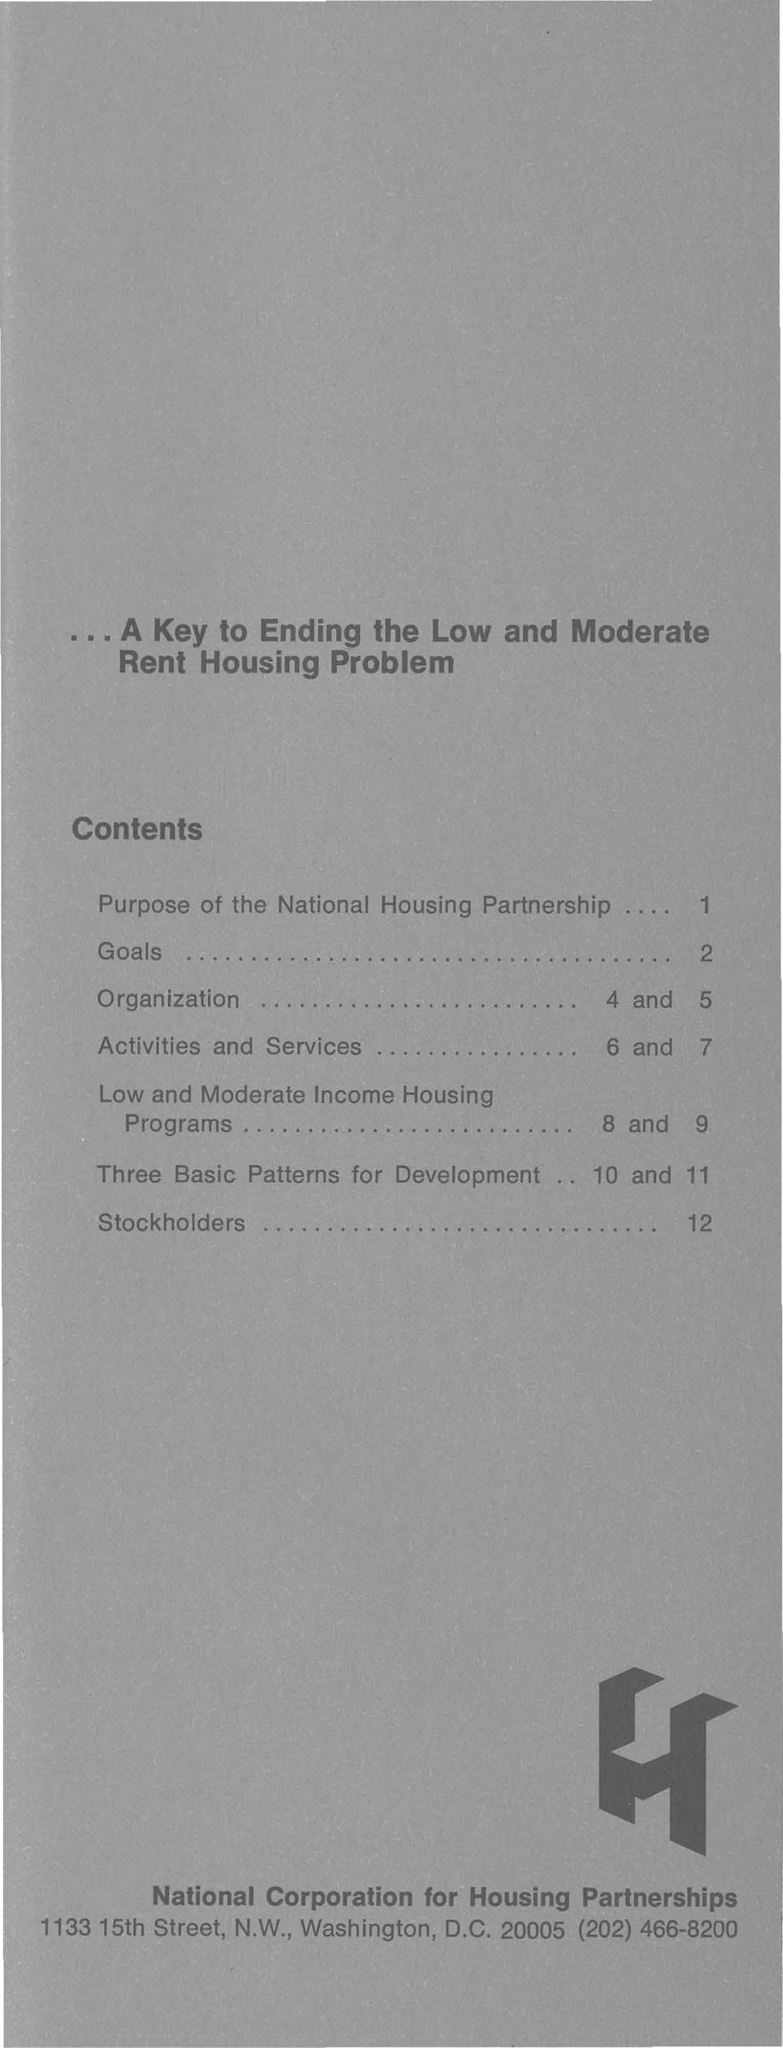What is the second title in this document?
Your answer should be compact. Contents. 